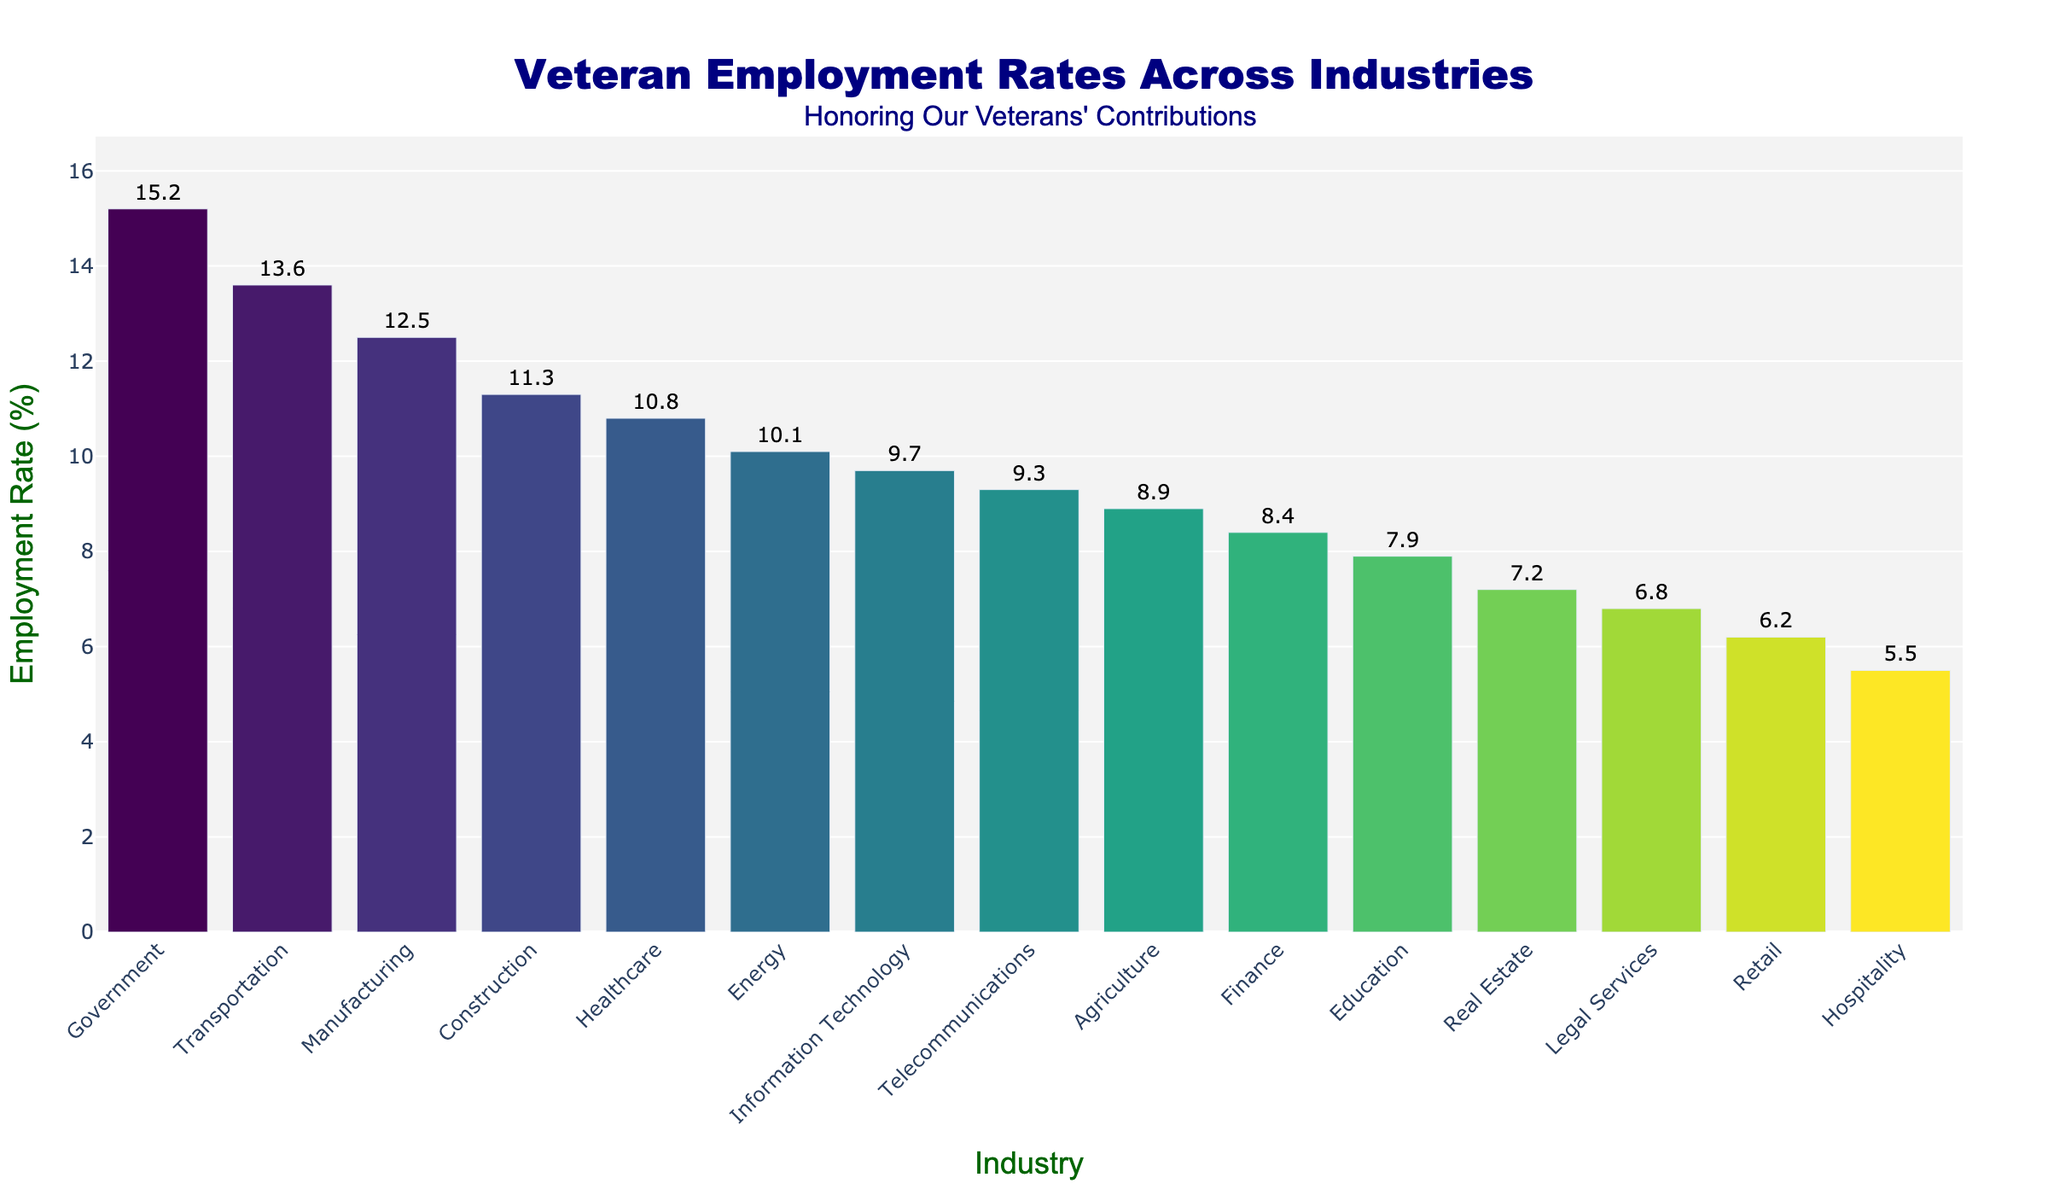Which industry has the highest veteran employment rate? By looking at the bar chart, identify the industry with the tallest bar. The bar representing the "Government" industry is the tallest, indicating the highest veteran employment rate.
Answer: Government Which industry has the lowest veteran employment rate? By looking at the bar chart, identify the industry with the shortest bar. The bar representing the "Hospitality" industry is the shortest, indicating the lowest veteran employment rate.
Answer: Hospitality How does the veteran employment rate in Healthcare compare to that in IT? Locate the bars for Healthcare and Information Technology. The bar for Healthcare is slightly higher than the bar for Information Technology. Therefore, Healthcare has a higher veteran employment rate than IT.
Answer: Healthcare has a higher rate than IT What is the difference in veteran employment rates between Manufacturing and Retail? Find and compare the heights of the bars for Manufacturing and Retail. The employment rate for Manufacturing is 12.5% and for Retail is 6.2%. Subtract the smaller from the larger: 12.5% - 6.2% = 6.3%.
Answer: 6.3% What is the average veteran employment rate across all industries? Add together the employment rates for each industry and then divide by the total number of industries. The sum is 155.3, and there are 15 industries. 155.3 / 15 ≈ 10.35%.
Answer: 10.35% How much higher is the veteran employment rate in the Government sector compared to the Energy sector? Locate and compare the heights of the bars for Government and Energy. The rate for Government is 15.2%, and for Energy is 10.1%. Subtract the smaller from the larger: 15.2% - 10.1% = 5.1%.
Answer: 5.1% What is the median veteran employment rate across the listed industries? Arrange the employment rates in ascending order and find the middle value. The rates are: 5.5, 6.2, 6.8, 7.2, 7.9, 8.4, 8.9, 9.3, 9.7, 10.1, 10.8, 11.3, 12.5, 13.6, 15.2. The median (8th value) is 9.3%.
Answer: 9.3% Which industry has a veteran employment rate closest to 10%? Look for the bar with an employment rate near 10%. Both Energy (10.1%) and Healthcare (10.8%) are close, but Energy is the closest to 10%.
Answer: Energy By how much does the veteran employment rate in Construction exceed that in Education? Locate and compare the heights of the bars for Construction and Education. The rate for Construction is 11.3%, and for Education is 7.9%. Subtract the smaller from the larger: 11.3% - 7.9% = 3.4%.
Answer: 3.4% 